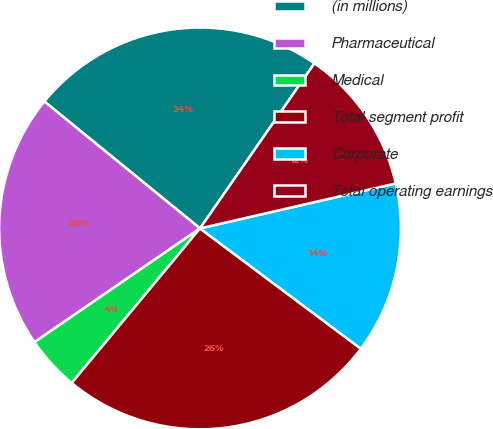Convert chart. <chart><loc_0><loc_0><loc_500><loc_500><pie_chart><fcel>(in millions)<fcel>Pharmaceutical<fcel>Medical<fcel>Total segment profit<fcel>Corporate<fcel>Total operating earnings<nl><fcel>23.76%<fcel>20.47%<fcel>4.39%<fcel>25.81%<fcel>13.81%<fcel>11.76%<nl></chart> 